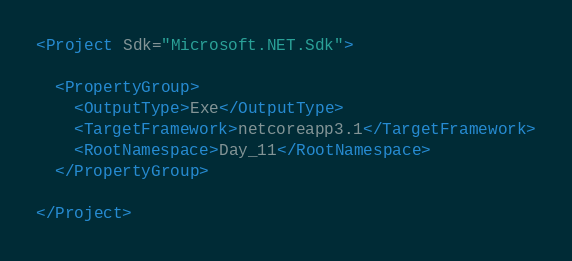Convert code to text. <code><loc_0><loc_0><loc_500><loc_500><_XML_><Project Sdk="Microsoft.NET.Sdk">

  <PropertyGroup>
    <OutputType>Exe</OutputType>
    <TargetFramework>netcoreapp3.1</TargetFramework>
    <RootNamespace>Day_11</RootNamespace>
  </PropertyGroup>

</Project>
</code> 